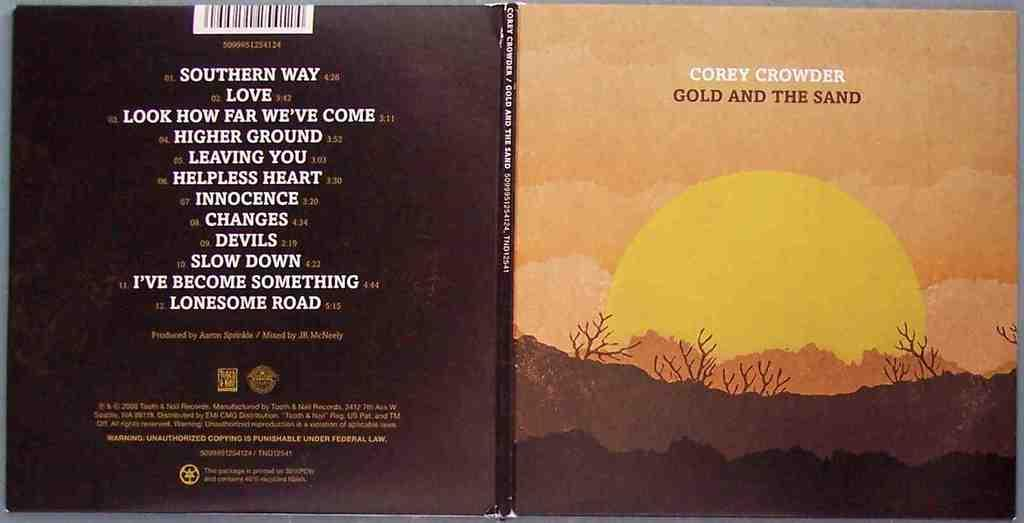<image>
Create a compact narrative representing the image presented. a book that says 'corey crowder gold and the sand' 